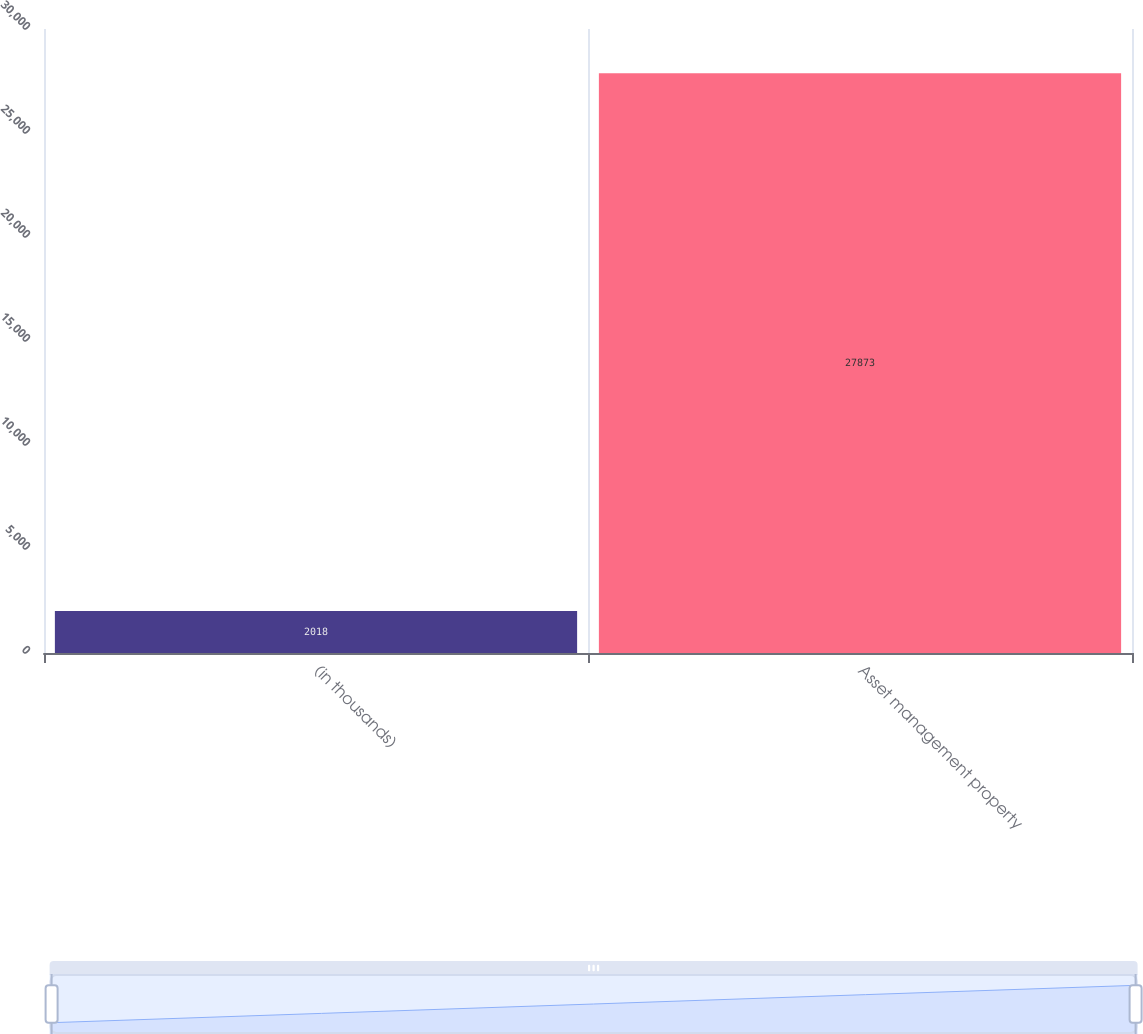Convert chart to OTSL. <chart><loc_0><loc_0><loc_500><loc_500><bar_chart><fcel>(in thousands)<fcel>Asset management property<nl><fcel>2018<fcel>27873<nl></chart> 